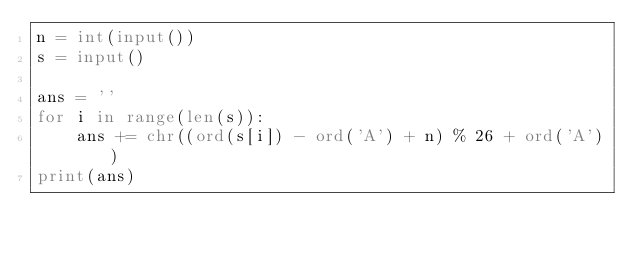<code> <loc_0><loc_0><loc_500><loc_500><_Python_>n = int(input())
s = input()

ans = ''
for i in range(len(s)):
    ans += chr((ord(s[i]) - ord('A') + n) % 26 + ord('A'))
print(ans)</code> 